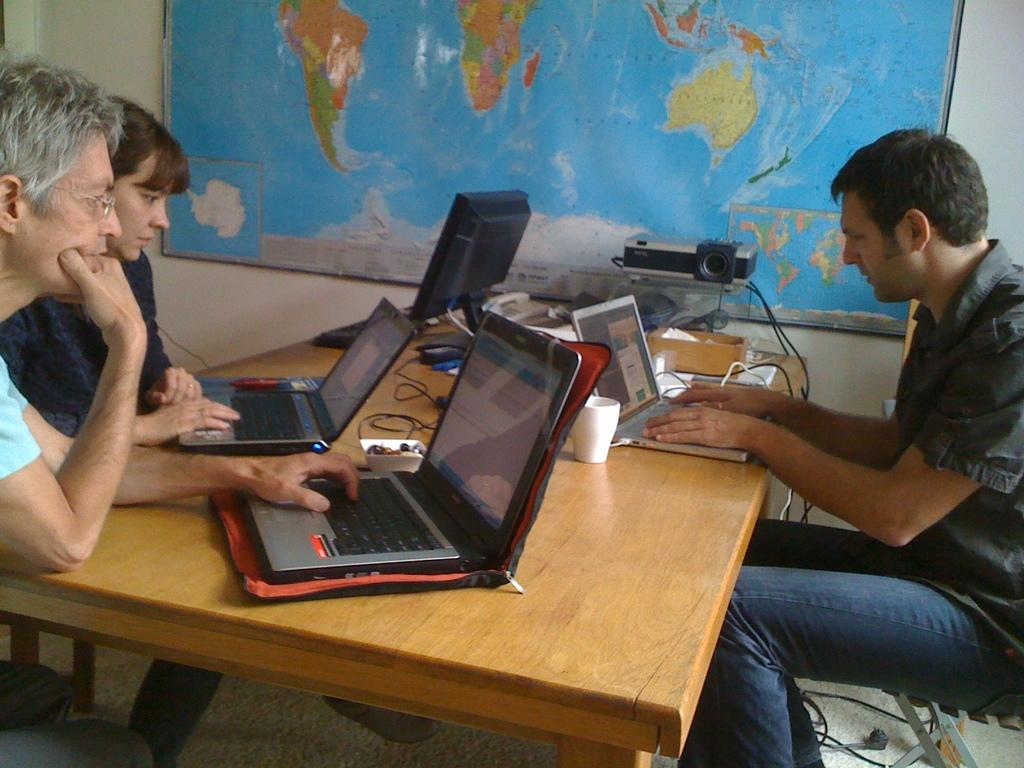How many people are present in the image? There are three people seated in the image. What are the people doing in the image? The people are using their laptops on a table. Are there any other electronic devices visible in the image? Yes, there is a desktop computer in the image. What can be seen hanging on the wall in the image? A map is hanging on the wall. What type of wax can be seen melting on the desktop computer in the image? There is no wax present, let alone melting, on the desktop computer in the image. 